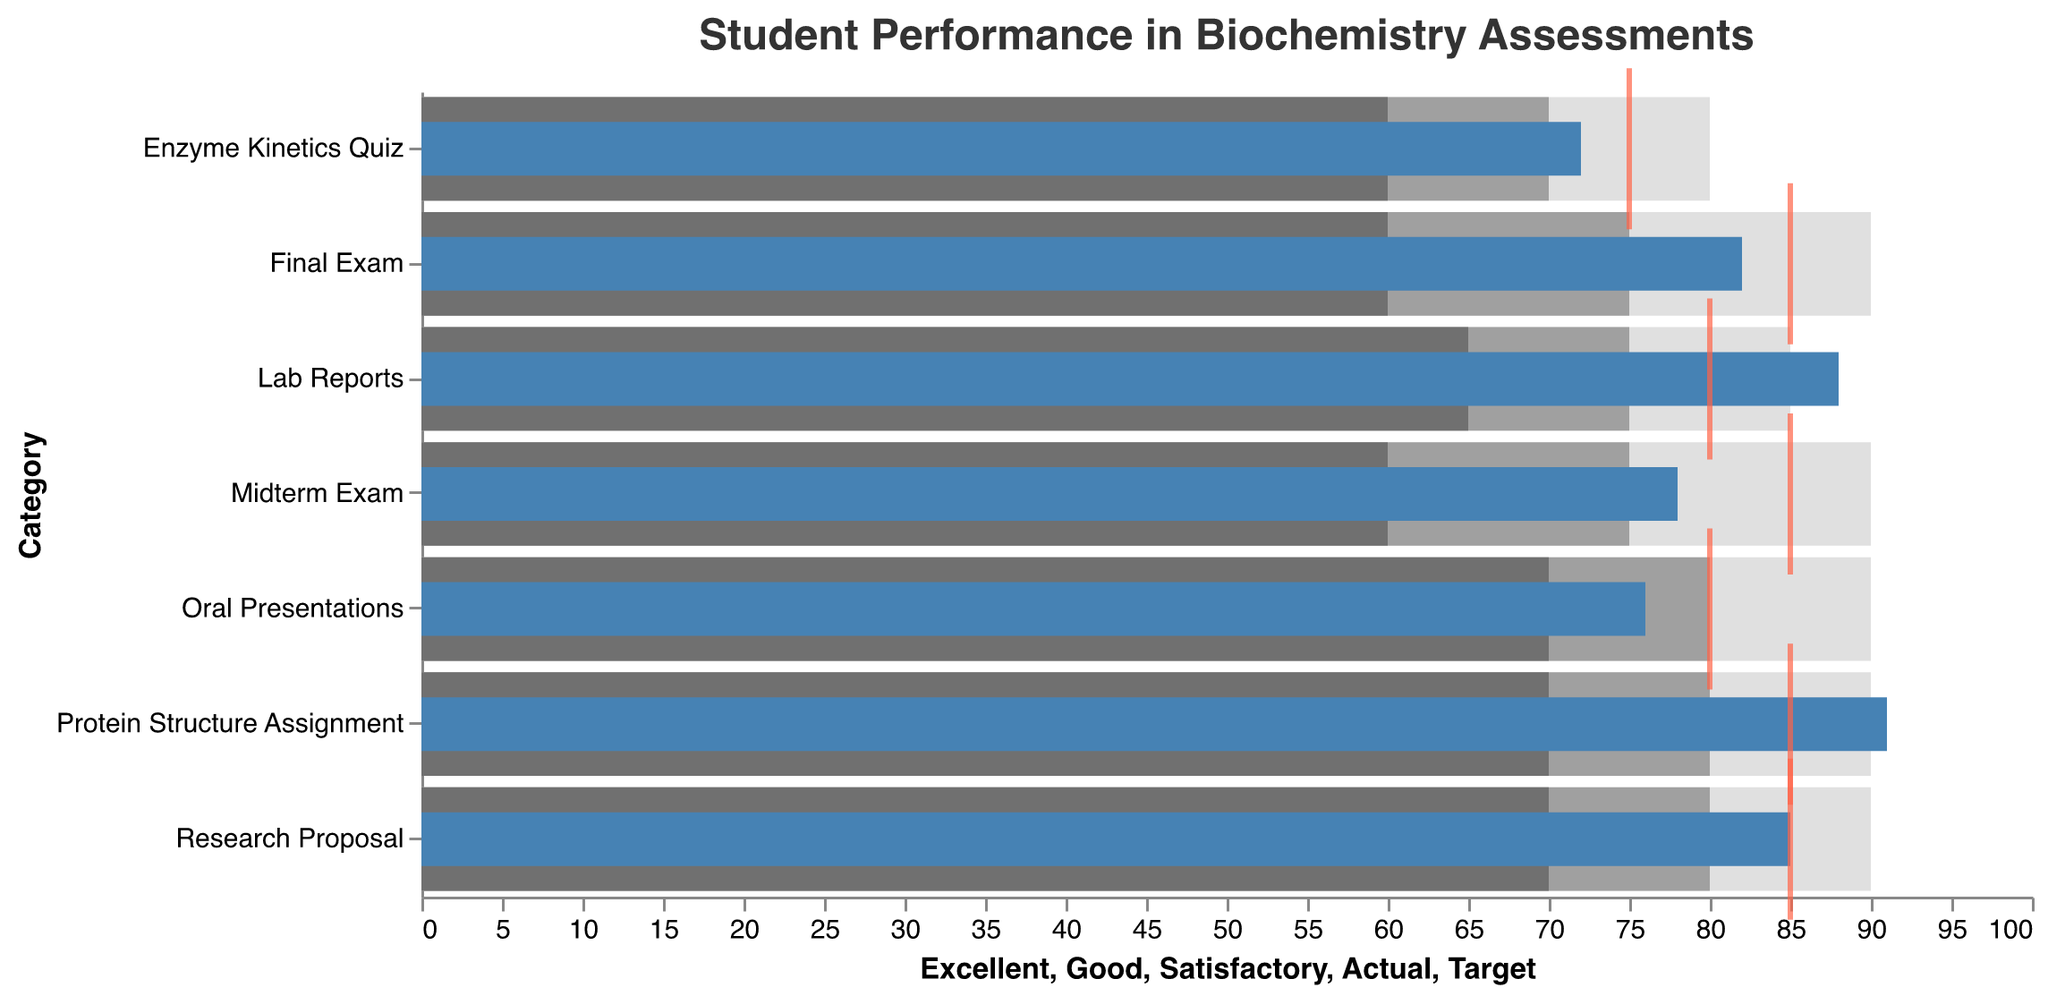What is the title of the figure? The title of the figure is usually located at the top of the chart. According to the description, the title is "Student Performance in Biochemistry Assessments."
Answer: Student Performance in Biochemistry Assessments What color represents the 'Actual' performance in the chart? The bullet chart uses different colors to represent various performance levels. According to the description, the 'Actual' performance is represented by a blue color.
Answer: Blue What is the target score for "Enzyme Kinetics Quiz"? The target score for each category is marked by a tick. For "Enzyme Kinetics Quiz," it is aligned with the value 75 on the horizontal axis.
Answer: 75 Which assessment shows the highest 'Actual' score? To answer this, look at the lengths of the 'Actual' performance bars. The "Protein Structure Assignment" has the longest bar relative to the other assessments, indicating it has the highest 'Actual' score of 91.
Answer: Protein Structure Assignment How many assessments have 'Actual' scores that meet or exceed their target scores? Compare the 'Actual' performance bars to the ticks representing target scores. "Lab Reports," "Research Proposal," and "Protein Structure Assignment" have 'Actual' scores that meet or exceed their targets.
Answer: 3 What is the difference between the 'Actual' and 'Target' scores for "Oral Presentations"? Subtract the 'Actual' score of "Oral Presentations" (76) from its 'Target' score (80). The difference is 80 - 76.
Answer: 4 Which assessments have 'Poor' performance ranges starting at 0? Look at the 'Poor' range values. All assessments have 'Poor' performance ranges starting at 0, as per the provided data.
Answer: All assessments If we calculate the average 'Actual' score for all assessments, what would it be? Sum the 'Actual' scores (78 + 82 + 88 + 76 + 85 + 72 + 91) and divide by the number of assessments (7). The average is (78 + 82 + 88 + 76 + 85 + 72 + 91) / 7.
Answer: 81.71 By how many points does the 'Actual' score for "Midterm Exam" fall short of 'Excellent'? Subtract the 'Actual' score of "Midterm Exam" (78) from its 'Excellent' range start (90). The difference is 90 - 78.
Answer: 12 Among the assessments with a target score of 85, which one has the closest 'Actual' score to its target? Compare the 'Actual' scores of assessments with a target score of 85: Midterm Exam (78), Final Exam (82), Research Proposal (85), Protein Structure Assignment (91). "Research Proposal" has an 'Actual' score equal to its target (85).
Answer: Research Proposal 